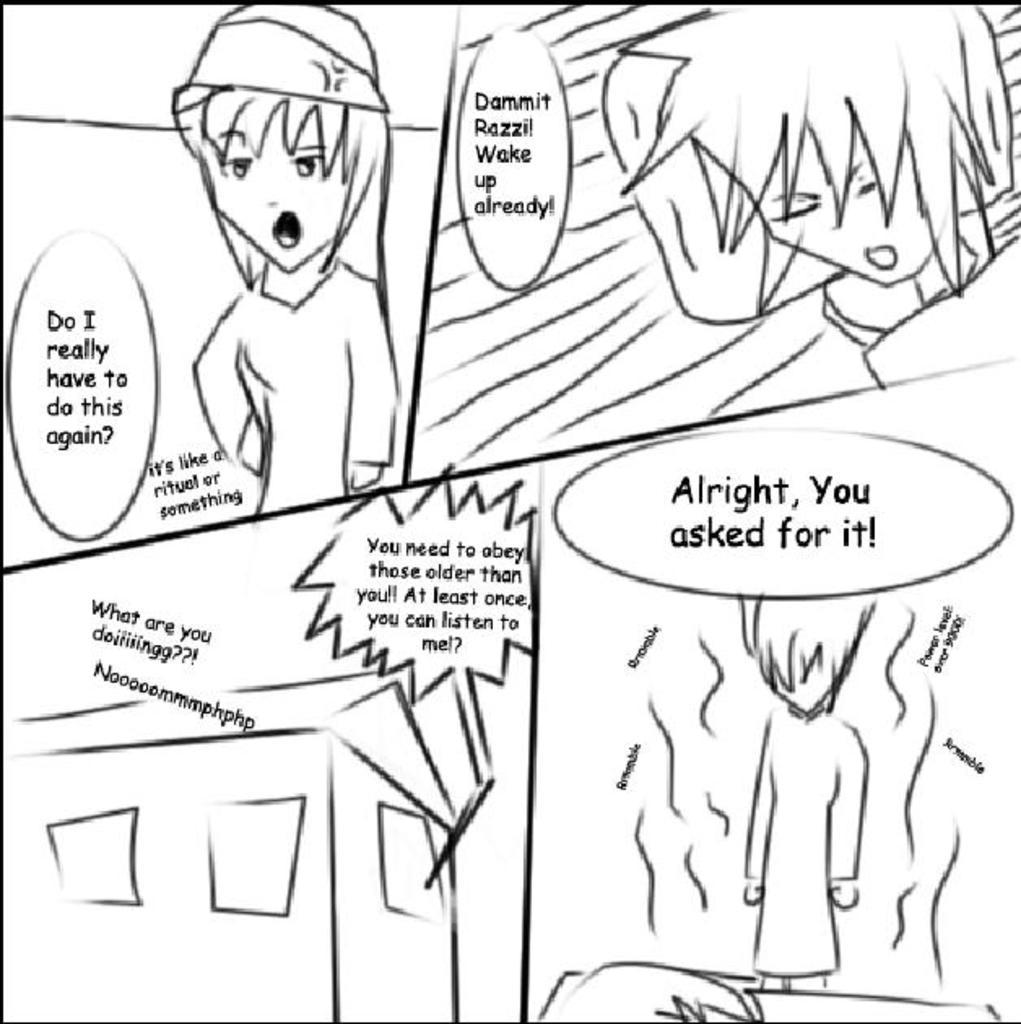What type of images are present in the picture? There are cartoon images in the picture. Is there any text present in the image? Yes, there is text written on the image. What color is the background of the image? The background of the image is white. What type of voice can be heard coming from the cartoon characters in the image? There is no sound or voice present in the image, as it is a static picture. 